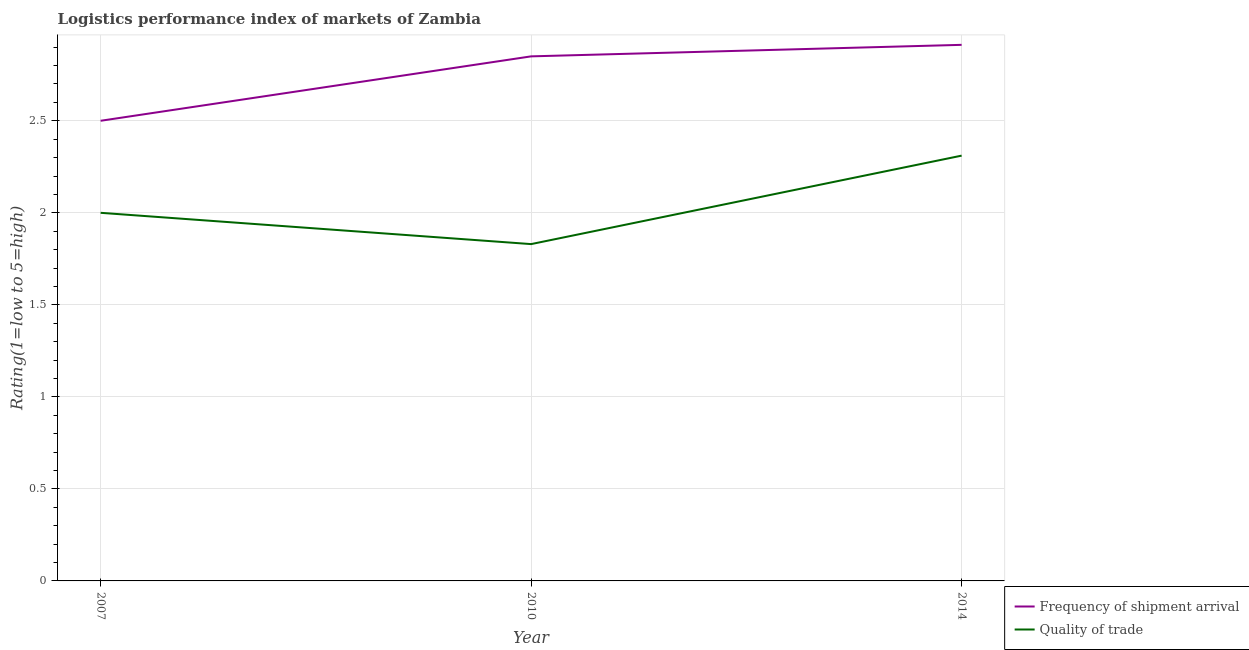How many different coloured lines are there?
Ensure brevity in your answer.  2. Does the line corresponding to lpi quality of trade intersect with the line corresponding to lpi of frequency of shipment arrival?
Your response must be concise. No. What is the lpi quality of trade in 2010?
Provide a succinct answer. 1.83. Across all years, what is the maximum lpi of frequency of shipment arrival?
Make the answer very short. 2.91. Across all years, what is the minimum lpi of frequency of shipment arrival?
Make the answer very short. 2.5. In which year was the lpi of frequency of shipment arrival maximum?
Give a very brief answer. 2014. In which year was the lpi of frequency of shipment arrival minimum?
Provide a short and direct response. 2007. What is the total lpi quality of trade in the graph?
Keep it short and to the point. 6.14. What is the difference between the lpi quality of trade in 2010 and that in 2014?
Your answer should be compact. -0.48. What is the difference between the lpi quality of trade in 2014 and the lpi of frequency of shipment arrival in 2010?
Your answer should be very brief. -0.54. What is the average lpi of frequency of shipment arrival per year?
Your answer should be very brief. 2.75. In the year 2010, what is the difference between the lpi quality of trade and lpi of frequency of shipment arrival?
Make the answer very short. -1.02. What is the ratio of the lpi quality of trade in 2010 to that in 2014?
Give a very brief answer. 0.79. What is the difference between the highest and the second highest lpi of frequency of shipment arrival?
Keep it short and to the point. 0.06. What is the difference between the highest and the lowest lpi of frequency of shipment arrival?
Your answer should be compact. 0.41. In how many years, is the lpi quality of trade greater than the average lpi quality of trade taken over all years?
Give a very brief answer. 1. Is the sum of the lpi of frequency of shipment arrival in 2007 and 2014 greater than the maximum lpi quality of trade across all years?
Provide a succinct answer. Yes. Is the lpi quality of trade strictly greater than the lpi of frequency of shipment arrival over the years?
Give a very brief answer. No. How many lines are there?
Your response must be concise. 2. How many years are there in the graph?
Your answer should be compact. 3. What is the difference between two consecutive major ticks on the Y-axis?
Offer a terse response. 0.5. Are the values on the major ticks of Y-axis written in scientific E-notation?
Your answer should be compact. No. Where does the legend appear in the graph?
Offer a terse response. Bottom right. How many legend labels are there?
Your answer should be very brief. 2. What is the title of the graph?
Give a very brief answer. Logistics performance index of markets of Zambia. What is the label or title of the Y-axis?
Make the answer very short. Rating(1=low to 5=high). What is the Rating(1=low to 5=high) in Frequency of shipment arrival in 2007?
Give a very brief answer. 2.5. What is the Rating(1=low to 5=high) of Frequency of shipment arrival in 2010?
Keep it short and to the point. 2.85. What is the Rating(1=low to 5=high) of Quality of trade in 2010?
Offer a terse response. 1.83. What is the Rating(1=low to 5=high) in Frequency of shipment arrival in 2014?
Ensure brevity in your answer.  2.91. What is the Rating(1=low to 5=high) in Quality of trade in 2014?
Your response must be concise. 2.31. Across all years, what is the maximum Rating(1=low to 5=high) of Frequency of shipment arrival?
Keep it short and to the point. 2.91. Across all years, what is the maximum Rating(1=low to 5=high) in Quality of trade?
Provide a short and direct response. 2.31. Across all years, what is the minimum Rating(1=low to 5=high) of Frequency of shipment arrival?
Provide a succinct answer. 2.5. Across all years, what is the minimum Rating(1=low to 5=high) of Quality of trade?
Make the answer very short. 1.83. What is the total Rating(1=low to 5=high) of Frequency of shipment arrival in the graph?
Offer a terse response. 8.26. What is the total Rating(1=low to 5=high) in Quality of trade in the graph?
Your answer should be compact. 6.14. What is the difference between the Rating(1=low to 5=high) of Frequency of shipment arrival in 2007 and that in 2010?
Offer a terse response. -0.35. What is the difference between the Rating(1=low to 5=high) in Quality of trade in 2007 and that in 2010?
Provide a short and direct response. 0.17. What is the difference between the Rating(1=low to 5=high) of Frequency of shipment arrival in 2007 and that in 2014?
Offer a very short reply. -0.41. What is the difference between the Rating(1=low to 5=high) of Quality of trade in 2007 and that in 2014?
Provide a succinct answer. -0.31. What is the difference between the Rating(1=low to 5=high) in Frequency of shipment arrival in 2010 and that in 2014?
Give a very brief answer. -0.06. What is the difference between the Rating(1=low to 5=high) of Quality of trade in 2010 and that in 2014?
Make the answer very short. -0.48. What is the difference between the Rating(1=low to 5=high) in Frequency of shipment arrival in 2007 and the Rating(1=low to 5=high) in Quality of trade in 2010?
Provide a short and direct response. 0.67. What is the difference between the Rating(1=low to 5=high) in Frequency of shipment arrival in 2007 and the Rating(1=low to 5=high) in Quality of trade in 2014?
Keep it short and to the point. 0.19. What is the difference between the Rating(1=low to 5=high) in Frequency of shipment arrival in 2010 and the Rating(1=low to 5=high) in Quality of trade in 2014?
Your answer should be compact. 0.54. What is the average Rating(1=low to 5=high) in Frequency of shipment arrival per year?
Offer a very short reply. 2.75. What is the average Rating(1=low to 5=high) of Quality of trade per year?
Make the answer very short. 2.05. In the year 2014, what is the difference between the Rating(1=low to 5=high) in Frequency of shipment arrival and Rating(1=low to 5=high) in Quality of trade?
Your answer should be compact. 0.6. What is the ratio of the Rating(1=low to 5=high) in Frequency of shipment arrival in 2007 to that in 2010?
Provide a short and direct response. 0.88. What is the ratio of the Rating(1=low to 5=high) of Quality of trade in 2007 to that in 2010?
Provide a short and direct response. 1.09. What is the ratio of the Rating(1=low to 5=high) of Frequency of shipment arrival in 2007 to that in 2014?
Make the answer very short. 0.86. What is the ratio of the Rating(1=low to 5=high) in Quality of trade in 2007 to that in 2014?
Make the answer very short. 0.87. What is the ratio of the Rating(1=low to 5=high) of Frequency of shipment arrival in 2010 to that in 2014?
Your answer should be very brief. 0.98. What is the ratio of the Rating(1=low to 5=high) of Quality of trade in 2010 to that in 2014?
Your response must be concise. 0.79. What is the difference between the highest and the second highest Rating(1=low to 5=high) of Frequency of shipment arrival?
Give a very brief answer. 0.06. What is the difference between the highest and the second highest Rating(1=low to 5=high) in Quality of trade?
Your answer should be very brief. 0.31. What is the difference between the highest and the lowest Rating(1=low to 5=high) in Frequency of shipment arrival?
Your response must be concise. 0.41. What is the difference between the highest and the lowest Rating(1=low to 5=high) of Quality of trade?
Make the answer very short. 0.48. 